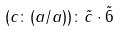<formula> <loc_0><loc_0><loc_500><loc_500>( c \colon ( a / a ) ) \colon \tilde { c } \cdot \tilde { 6 }</formula> 